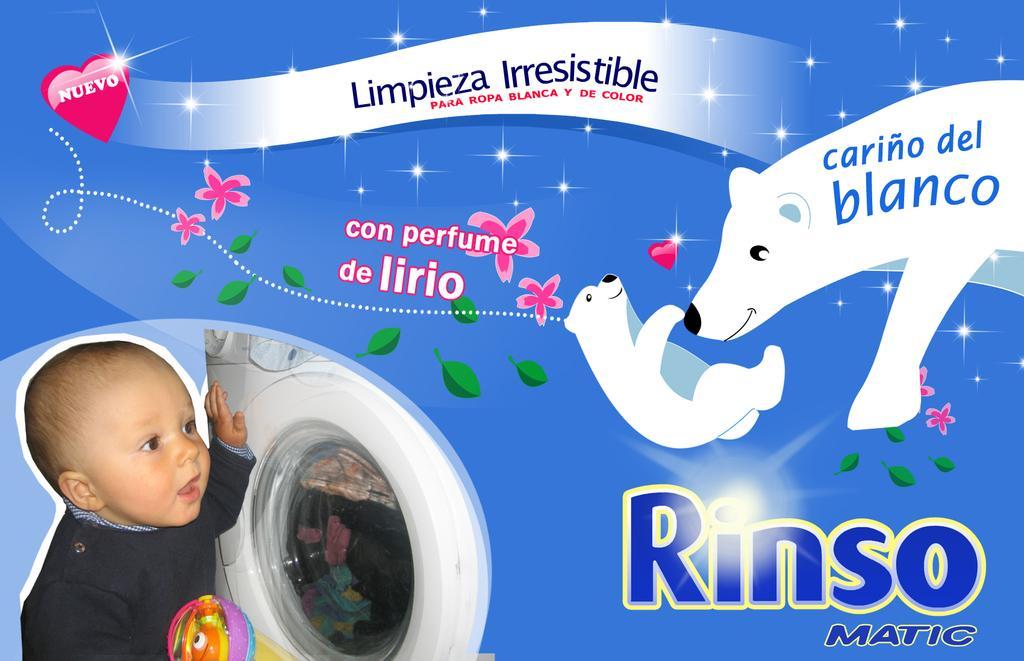Please provide a concise description of this image. In this image I see the animated pictures of bears and I see the truncated image of a baby over here and I see the washing machine and I see the depiction of leaves and flowers and I see few words written and it is blue in the background. 